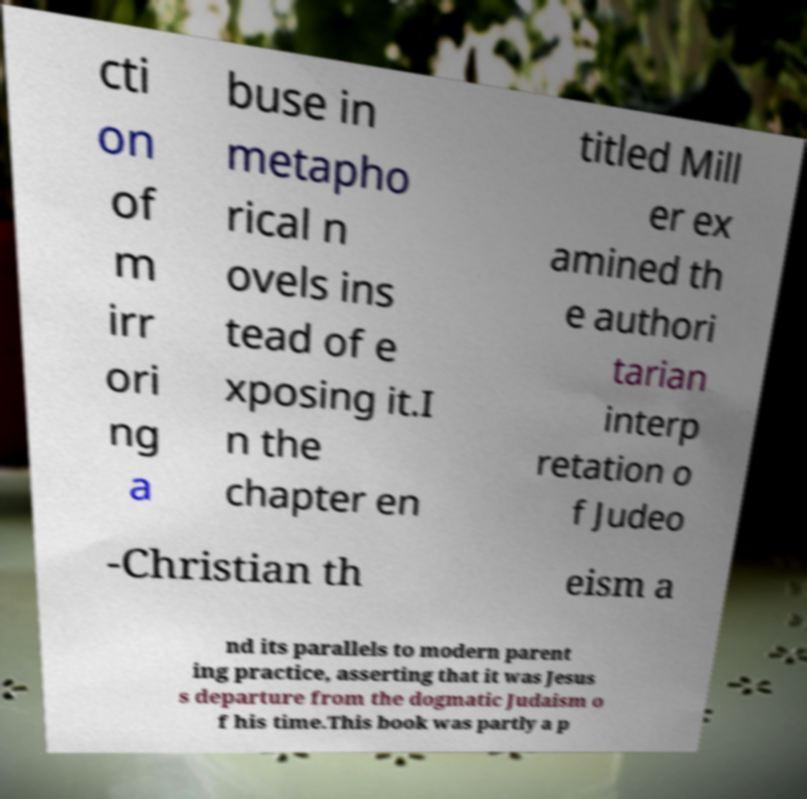Can you accurately transcribe the text from the provided image for me? cti on of m irr ori ng a buse in metapho rical n ovels ins tead of e xposing it.I n the chapter en titled Mill er ex amined th e authori tarian interp retation o f Judeo -Christian th eism a nd its parallels to modern parent ing practice, asserting that it was Jesus s departure from the dogmatic Judaism o f his time.This book was partly a p 